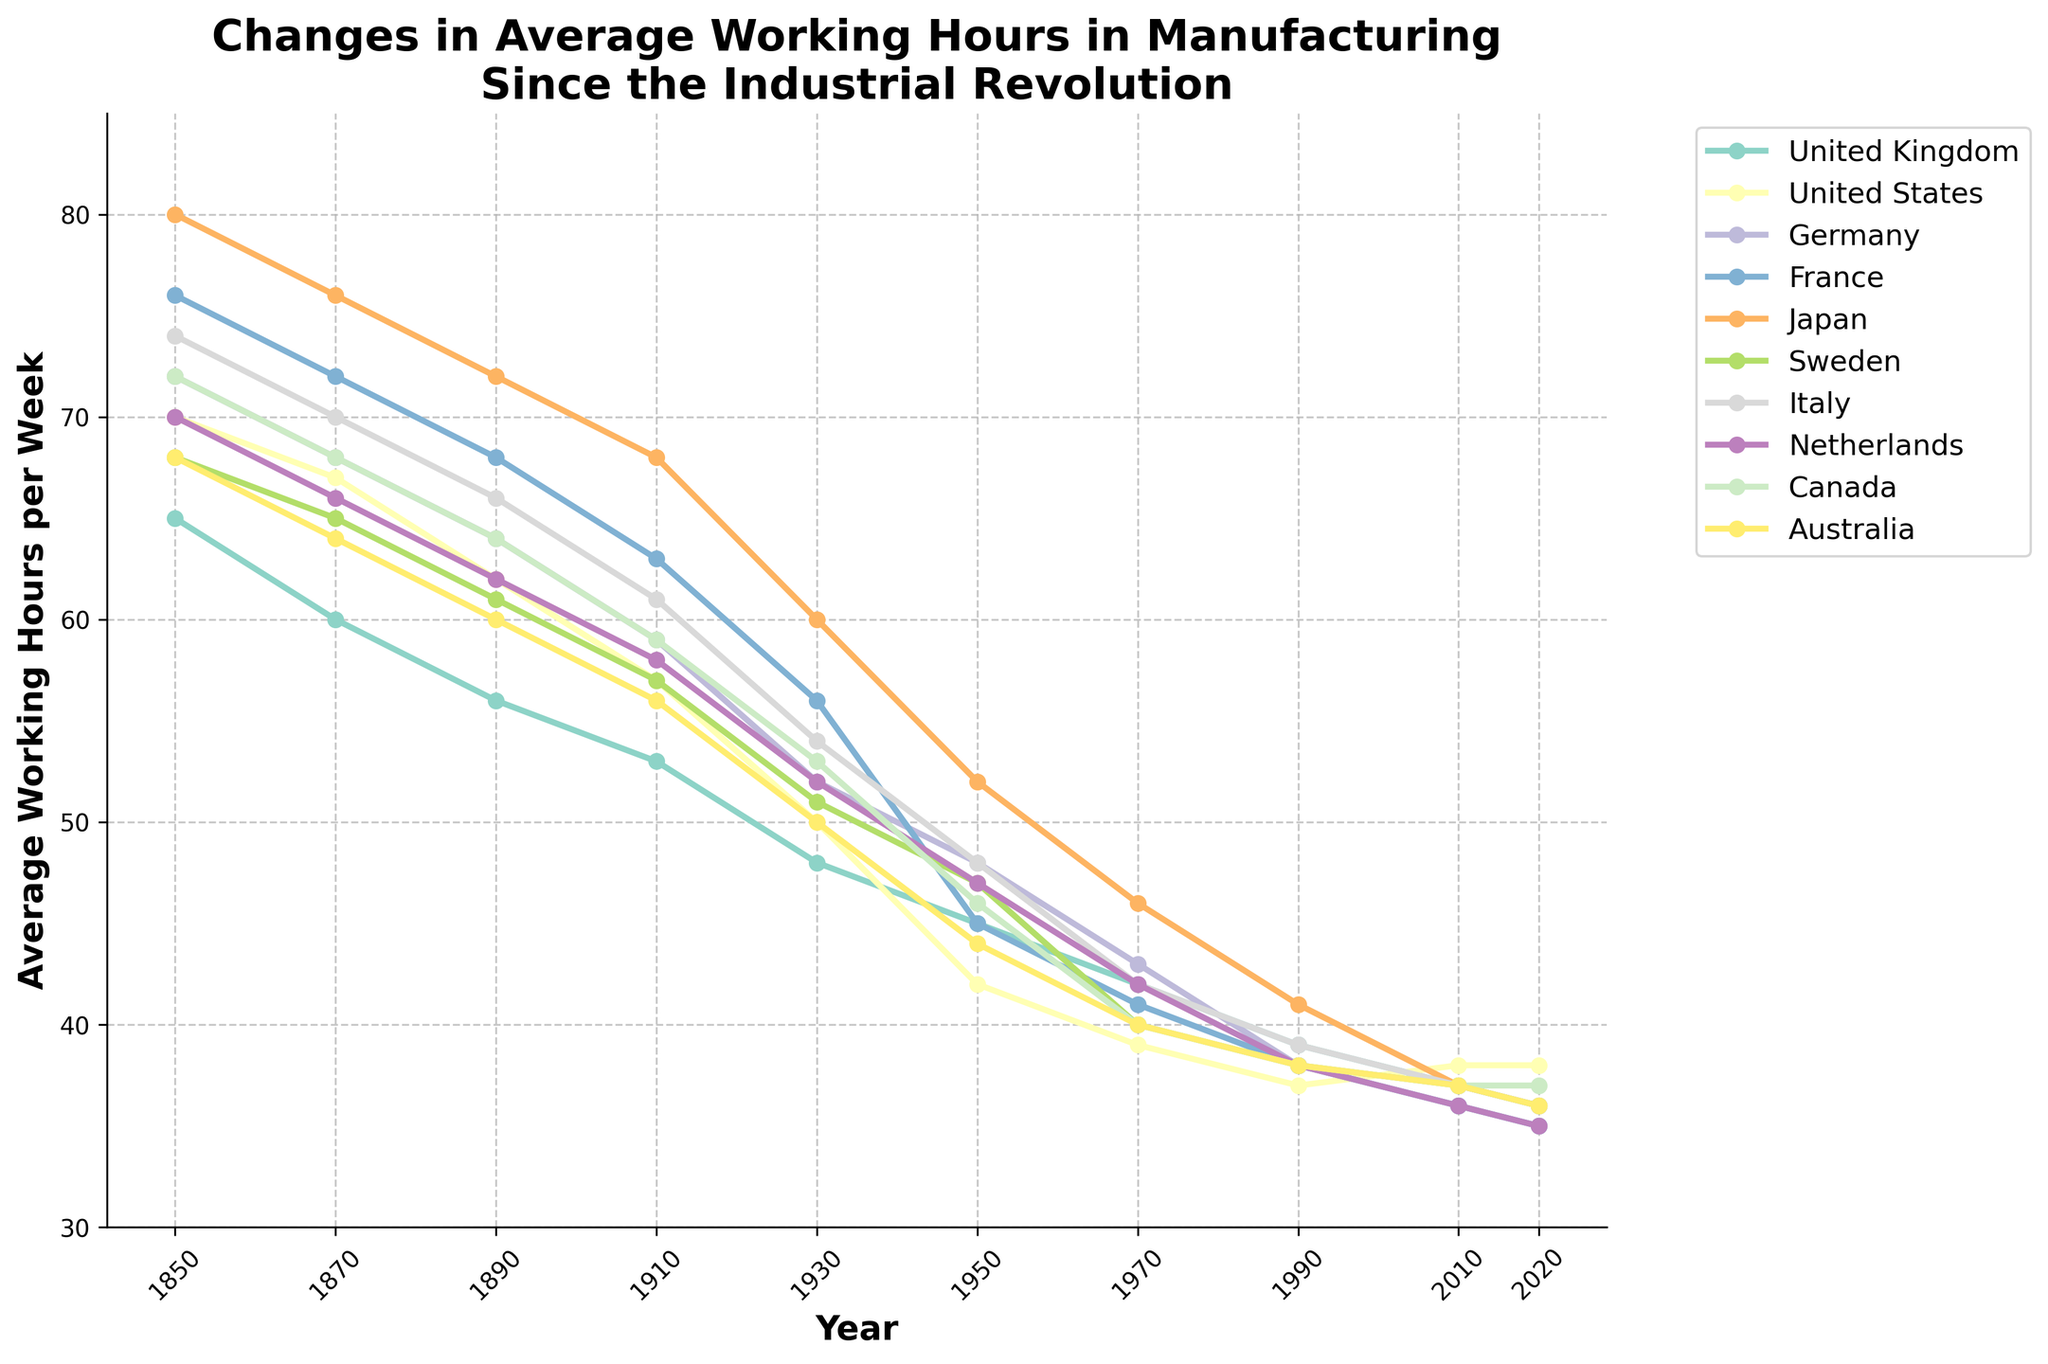Which country had the highest average working hours per week in 1850? Observing the line chart, we can see that Japan has the highest starting point in 1850 with 80 hours.
Answer: Japan What is the difference in average working hours per week between the United States and Germany in 2020? From the line chart, the United States shows 38 hours and Germany shows 35 hours in 2020. The difference is 38 - 35.
Answer: 3 hours Which country experienced the largest reduction in working hours per week from 1870 to 1910? Looking at the line trends, France had 72 hours in 1870 and 63 hours in 1910, so a decrease of 9 hours. No other country shows a higher reduction in this period.
Answer: France What is the average working hours per week in 1950 for all the countries combined? Adding the working hours in 1950: 45 (UK) + 42 (US) + 48 (Germany) + 45 (France) + 52 (Japan) + 47 (Sweden) + 48 (Italy) + 47 (Netherlands) + 46 (Canada) + 44 (Australia) = 464. Divide by the number of countries, which is 10. 464 / 10 = 46.4.
Answer: 46.4 hours Between 1990 and 2010, which country had more consistent working hours without much fluctuation? Observing the line chart, the United States line stays constant at 37 to 38 hours over 1990 and 2010 showing barely any fluctuation.
Answer: United States In which decade did Germany's average working hours per week drop below 60? Following Germany's line, we see that it drops below 60 between 1910 (59 hours) and 1930 (52 hours).
Answer: 1910s How do the average working hours in 2020 for Australia compare to those in 1950? From the line chart, Australia's average working hours in 1950 were 44, and in 2020, it is 36. Subtracting these, the reduction is 44 - 36.
Answer: 8 hours less Which country's working hours decreased the most sharply between 1930 and 1950? Observing the chart, Japan has the steepest decline with hours falling from 60 in 1930 to 52 in 1950, a difference of 8 hours.
Answer: Japan In 1910, how many countries had average working hours of 60 or more per week? Looking at the chart in 1910, Germany (59 hours) and all others have fewer than 60 hours per week.
Answer: 0 countries 